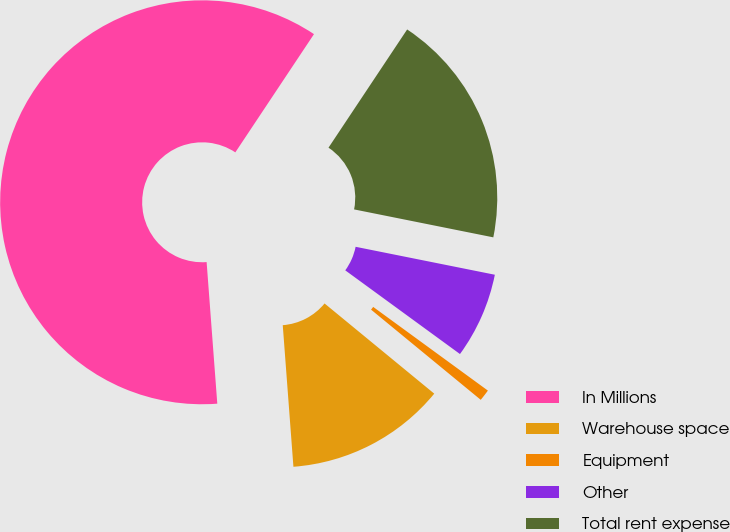<chart> <loc_0><loc_0><loc_500><loc_500><pie_chart><fcel>In Millions<fcel>Warehouse space<fcel>Equipment<fcel>Other<fcel>Total rent expense<nl><fcel>60.54%<fcel>12.85%<fcel>0.92%<fcel>6.88%<fcel>18.81%<nl></chart> 